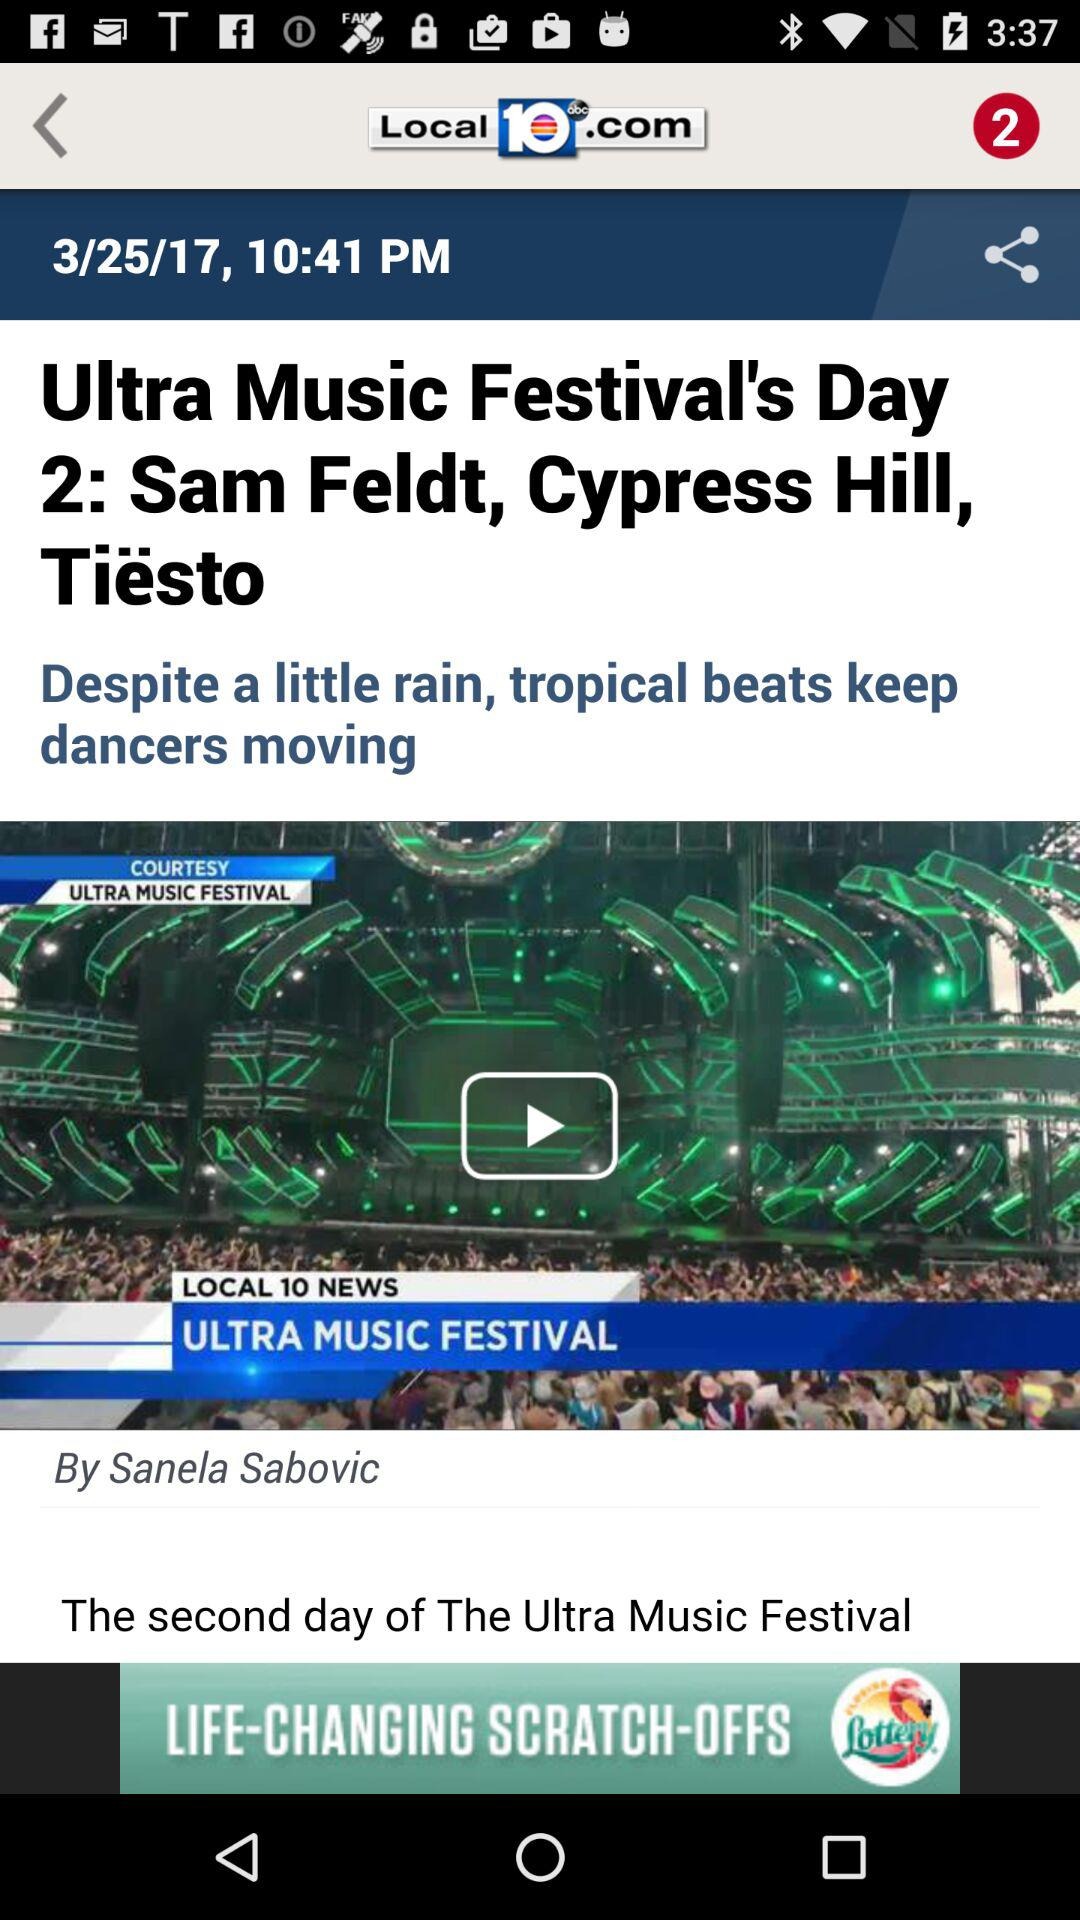What is the headline of the content? The headline is "Ultra Music Festival's Day 2: Sam Feldt, Cypress Hill, Tiësto". 